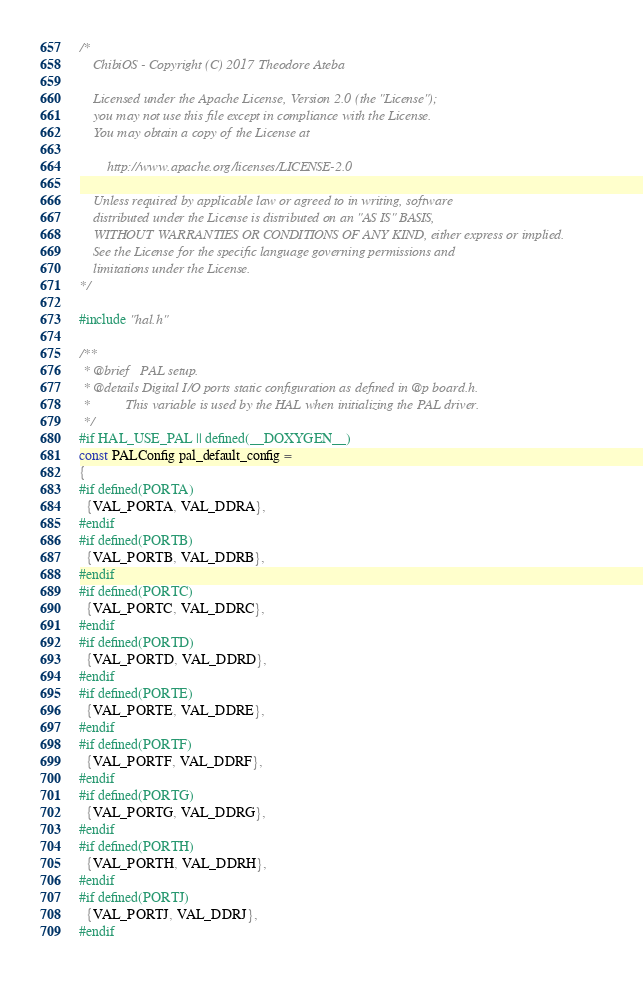Convert code to text. <code><loc_0><loc_0><loc_500><loc_500><_C_>/*
    ChibiOS - Copyright (C) 2017 Theodore Ateba

    Licensed under the Apache License, Version 2.0 (the "License");
    you may not use this file except in compliance with the License.
    You may obtain a copy of the License at

        http://www.apache.org/licenses/LICENSE-2.0

    Unless required by applicable law or agreed to in writing, software
    distributed under the License is distributed on an "AS IS" BASIS,
    WITHOUT WARRANTIES OR CONDITIONS OF ANY KIND, either express or implied.
    See the License for the specific language governing permissions and
    limitations under the License.
*/

#include "hal.h"

/**
 * @brief   PAL setup.
 * @details Digital I/O ports static configuration as defined in @p board.h.
 *          This variable is used by the HAL when initializing the PAL driver.
 */
#if HAL_USE_PAL || defined(__DOXYGEN__)
const PALConfig pal_default_config =
{
#if defined(PORTA)
  {VAL_PORTA, VAL_DDRA},
#endif
#if defined(PORTB)
  {VAL_PORTB, VAL_DDRB},
#endif
#if defined(PORTC)
  {VAL_PORTC, VAL_DDRC},
#endif
#if defined(PORTD)
  {VAL_PORTD, VAL_DDRD},
#endif
#if defined(PORTE)
  {VAL_PORTE, VAL_DDRE},
#endif
#if defined(PORTF)
  {VAL_PORTF, VAL_DDRF},
#endif
#if defined(PORTG)
  {VAL_PORTG, VAL_DDRG},
#endif
#if defined(PORTH)
  {VAL_PORTH, VAL_DDRH},
#endif
#if defined(PORTJ)
  {VAL_PORTJ, VAL_DDRJ},
#endif</code> 